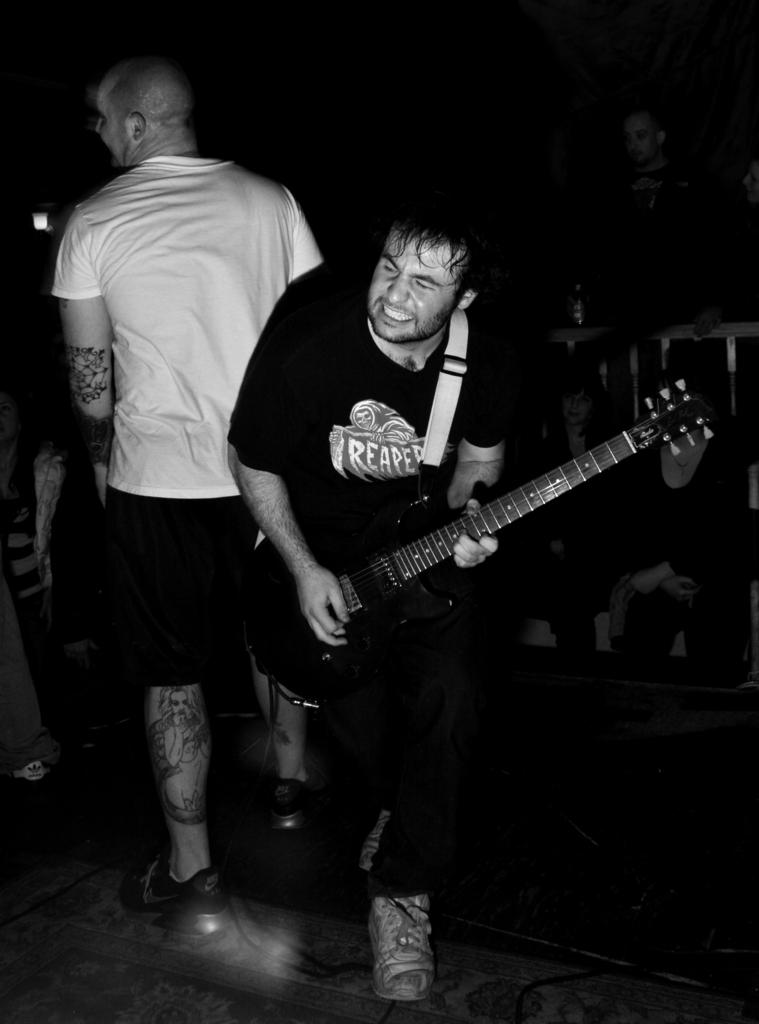What is the man in the image doing? The man is playing a guitar in the image. What is the man wearing? The man is wearing a black costume. How many people are in the image? There are two people in the image. What is the second man wearing? The second man is wearing a white t-shirt. What type of nerve can be seen in the image? There is no nerve visible in the image; it features two men, one playing a guitar and the other wearing a white t-shirt. 